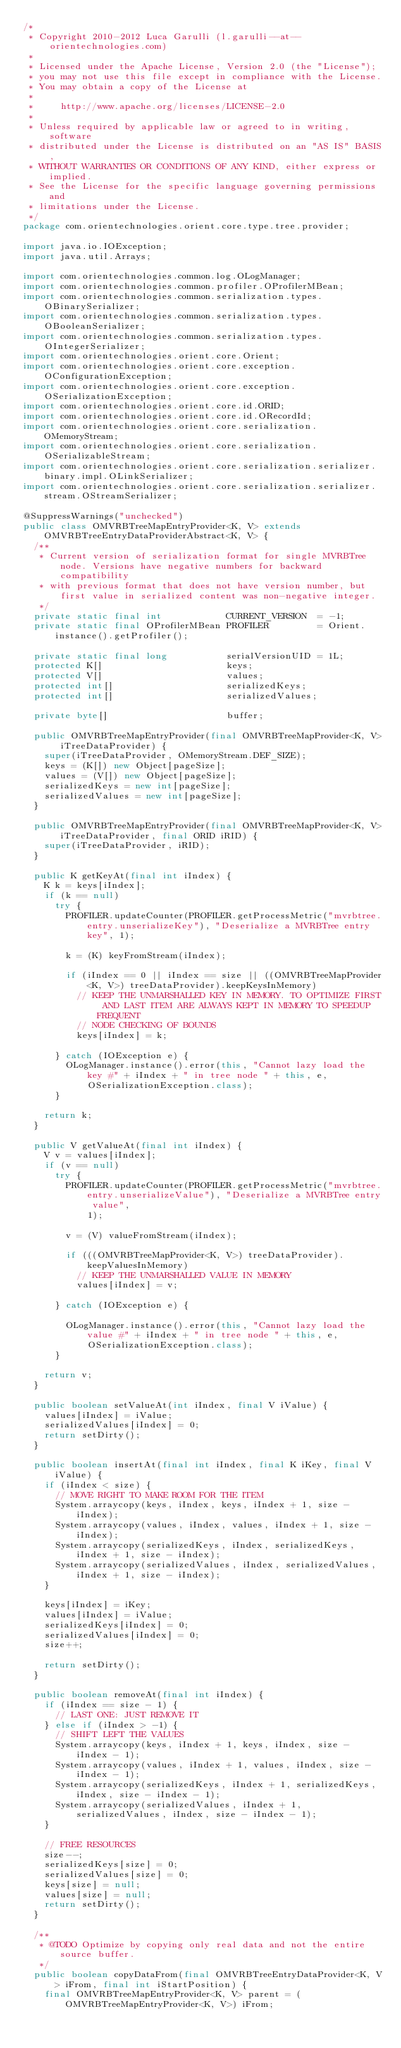<code> <loc_0><loc_0><loc_500><loc_500><_Java_>/*
 * Copyright 2010-2012 Luca Garulli (l.garulli--at--orientechnologies.com)
 *
 * Licensed under the Apache License, Version 2.0 (the "License");
 * you may not use this file except in compliance with the License.
 * You may obtain a copy of the License at
 *
 *     http://www.apache.org/licenses/LICENSE-2.0
 *
 * Unless required by applicable law or agreed to in writing, software
 * distributed under the License is distributed on an "AS IS" BASIS,
 * WITHOUT WARRANTIES OR CONDITIONS OF ANY KIND, either express or implied.
 * See the License for the specific language governing permissions and
 * limitations under the License.
 */
package com.orientechnologies.orient.core.type.tree.provider;

import java.io.IOException;
import java.util.Arrays;

import com.orientechnologies.common.log.OLogManager;
import com.orientechnologies.common.profiler.OProfilerMBean;
import com.orientechnologies.common.serialization.types.OBinarySerializer;
import com.orientechnologies.common.serialization.types.OBooleanSerializer;
import com.orientechnologies.common.serialization.types.OIntegerSerializer;
import com.orientechnologies.orient.core.Orient;
import com.orientechnologies.orient.core.exception.OConfigurationException;
import com.orientechnologies.orient.core.exception.OSerializationException;
import com.orientechnologies.orient.core.id.ORID;
import com.orientechnologies.orient.core.id.ORecordId;
import com.orientechnologies.orient.core.serialization.OMemoryStream;
import com.orientechnologies.orient.core.serialization.OSerializableStream;
import com.orientechnologies.orient.core.serialization.serializer.binary.impl.OLinkSerializer;
import com.orientechnologies.orient.core.serialization.serializer.stream.OStreamSerializer;

@SuppressWarnings("unchecked")
public class OMVRBTreeMapEntryProvider<K, V> extends OMVRBTreeEntryDataProviderAbstract<K, V> {
  /**
   * Current version of serialization format for single MVRBTree node. Versions have negative numbers for backward compatibility
   * with previous format that does not have version number, but first value in serialized content was non-negative integer.
   */
  private static final int            CURRENT_VERSION  = -1;
  private static final OProfilerMBean PROFILER         = Orient.instance().getProfiler();

  private static final long           serialVersionUID = 1L;
  protected K[]                       keys;
  protected V[]                       values;
  protected int[]                     serializedKeys;
  protected int[]                     serializedValues;

  private byte[]                      buffer;

  public OMVRBTreeMapEntryProvider(final OMVRBTreeMapProvider<K, V> iTreeDataProvider) {
    super(iTreeDataProvider, OMemoryStream.DEF_SIZE);
    keys = (K[]) new Object[pageSize];
    values = (V[]) new Object[pageSize];
    serializedKeys = new int[pageSize];
    serializedValues = new int[pageSize];
  }

  public OMVRBTreeMapEntryProvider(final OMVRBTreeMapProvider<K, V> iTreeDataProvider, final ORID iRID) {
    super(iTreeDataProvider, iRID);
  }

  public K getKeyAt(final int iIndex) {
    K k = keys[iIndex];
    if (k == null)
      try {
        PROFILER.updateCounter(PROFILER.getProcessMetric("mvrbtree.entry.unserializeKey"), "Deserialize a MVRBTree entry key", 1);

        k = (K) keyFromStream(iIndex);

        if (iIndex == 0 || iIndex == size || ((OMVRBTreeMapProvider<K, V>) treeDataProvider).keepKeysInMemory)
          // KEEP THE UNMARSHALLED KEY IN MEMORY. TO OPTIMIZE FIRST AND LAST ITEM ARE ALWAYS KEPT IN MEMORY TO SPEEDUP FREQUENT
          // NODE CHECKING OF BOUNDS
          keys[iIndex] = k;

      } catch (IOException e) {
        OLogManager.instance().error(this, "Cannot lazy load the key #" + iIndex + " in tree node " + this, e,
            OSerializationException.class);
      }

    return k;
  }

  public V getValueAt(final int iIndex) {
    V v = values[iIndex];
    if (v == null)
      try {
        PROFILER.updateCounter(PROFILER.getProcessMetric("mvrbtree.entry.unserializeValue"), "Deserialize a MVRBTree entry value",
            1);

        v = (V) valueFromStream(iIndex);

        if (((OMVRBTreeMapProvider<K, V>) treeDataProvider).keepValuesInMemory)
          // KEEP THE UNMARSHALLED VALUE IN MEMORY
          values[iIndex] = v;

      } catch (IOException e) {

        OLogManager.instance().error(this, "Cannot lazy load the value #" + iIndex + " in tree node " + this, e,
            OSerializationException.class);
      }

    return v;
  }

  public boolean setValueAt(int iIndex, final V iValue) {
    values[iIndex] = iValue;
    serializedValues[iIndex] = 0;
    return setDirty();
  }

  public boolean insertAt(final int iIndex, final K iKey, final V iValue) {
    if (iIndex < size) {
      // MOVE RIGHT TO MAKE ROOM FOR THE ITEM
      System.arraycopy(keys, iIndex, keys, iIndex + 1, size - iIndex);
      System.arraycopy(values, iIndex, values, iIndex + 1, size - iIndex);
      System.arraycopy(serializedKeys, iIndex, serializedKeys, iIndex + 1, size - iIndex);
      System.arraycopy(serializedValues, iIndex, serializedValues, iIndex + 1, size - iIndex);
    }

    keys[iIndex] = iKey;
    values[iIndex] = iValue;
    serializedKeys[iIndex] = 0;
    serializedValues[iIndex] = 0;
    size++;

    return setDirty();
  }

  public boolean removeAt(final int iIndex) {
    if (iIndex == size - 1) {
      // LAST ONE: JUST REMOVE IT
    } else if (iIndex > -1) {
      // SHIFT LEFT THE VALUES
      System.arraycopy(keys, iIndex + 1, keys, iIndex, size - iIndex - 1);
      System.arraycopy(values, iIndex + 1, values, iIndex, size - iIndex - 1);
      System.arraycopy(serializedKeys, iIndex + 1, serializedKeys, iIndex, size - iIndex - 1);
      System.arraycopy(serializedValues, iIndex + 1, serializedValues, iIndex, size - iIndex - 1);
    }

    // FREE RESOURCES
    size--;
    serializedKeys[size] = 0;
    serializedValues[size] = 0;
    keys[size] = null;
    values[size] = null;
    return setDirty();
  }

  /**
   * @TODO Optimize by copying only real data and not the entire source buffer.
   */
  public boolean copyDataFrom(final OMVRBTreeEntryDataProvider<K, V> iFrom, final int iStartPosition) {
    final OMVRBTreeMapEntryProvider<K, V> parent = (OMVRBTreeMapEntryProvider<K, V>) iFrom;</code> 